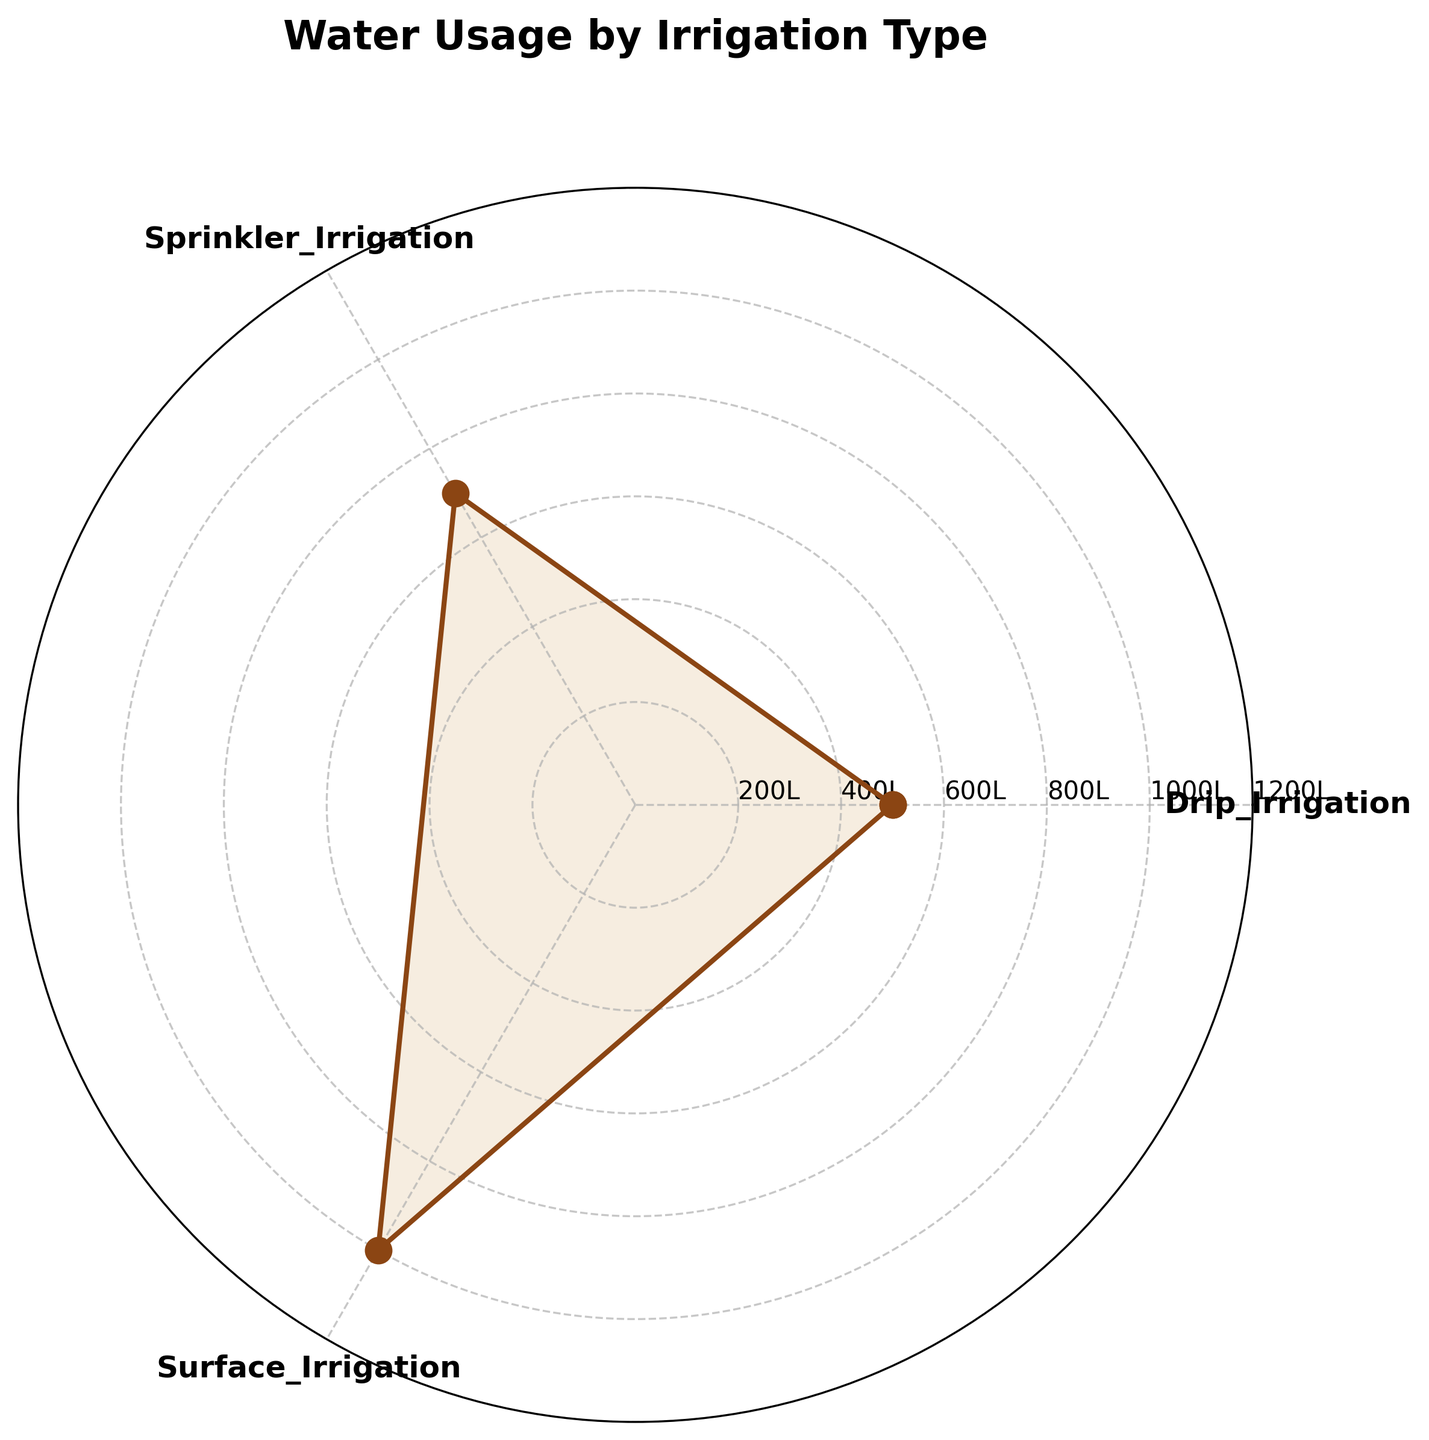What's the title of the figure? The title of the figure is typically displayed at the top and is often bolded or larger in font to stand out from other text. In this case, the title is "Water Usage by Irrigation Type."
Answer: Water Usage by Irrigation Type How many different irrigation types are shown in the chart? Counting the distinct labels around the chart, we see three different categories: Drip Irrigation, Sprinkler Irrigation, and Surface Irrigation.
Answer: 3 Which irrigation type uses the most water? To find which irrigation type uses the most water, look at the length of the lines from the center to the edge of the chart. The longest line corresponds to Surface Irrigation.
Answer: Surface Irrigation Which irrigation type uses the least amount of water? The shortest line from the center to the edge of the chart will indicate the least water usage. This line corresponds to Drip Irrigation.
Answer: Drip Irrigation How much more water does Surface Irrigation use compared to Drip Irrigation? From the chart: Surface Irrigation uses 1000 liters, Drip Irrigation uses 500 liters. Subtracting these values: 1000 - 500 = 500 liters.
Answer: 500 liters What is the difference in water usage between Surface Irrigation and Sprinkler Irrigation? Surface Irrigation uses 1000 liters, Sprinkler Irrigation uses 700 liters. Subtracting these values: 1000 - 700 = 300 liters.
Answer: 300 liters Rank the irrigation types from most to least water usage. Sort the irrigation types based on their water usage from the largest to the smallest value. Surface Irrigation (1000 liters), Sprinkler Irrigation (700 liters), Drip Irrigation (500 liters).
Answer: Surface Irrigation, Sprinkler Irrigation, Drip Irrigation Are the intervals on the radial axis evenly spaced? Examining the radial labels, the intervals progress in consistent steps (200L each), indicating even spacing.
Answer: Yes What is the average water usage across all irrigation types? Add the three water usage amounts: 500 + 700 + 1000 = 2200 liters. Divide by the number of types (3): 2200 ÷ 3 = ~733.33 liters.
Answer: ~733.33 liters Which irrigation types have water usage that exceeds the average water usage? The average water usage is ~733.33 liters. Comparing each type to this average: Surface Irrigation (1000 liters) and Sprinkler Irrigation (700 liters) exceed the average.
Answer: Surface Irrigation and Sprinkler Irrigation 